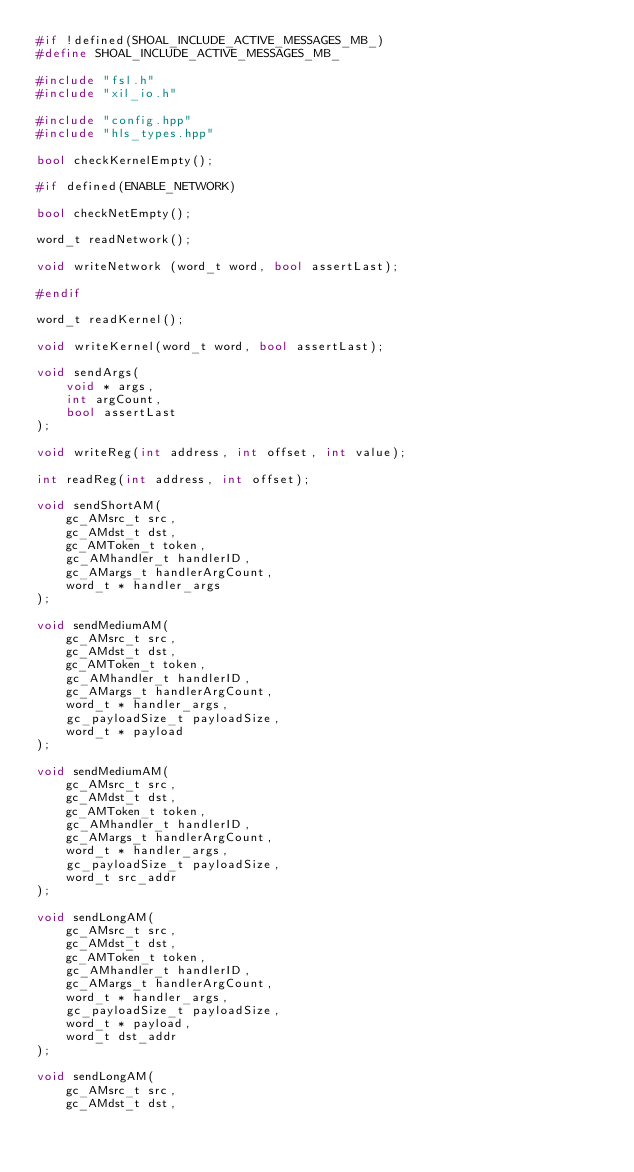Convert code to text. <code><loc_0><loc_0><loc_500><loc_500><_C++_>#if !defined(SHOAL_INCLUDE_ACTIVE_MESSAGES_MB_)
#define SHOAL_INCLUDE_ACTIVE_MESSAGES_MB_

#include "fsl.h"
#include "xil_io.h"

#include "config.hpp"
#include "hls_types.hpp"

bool checkKernelEmpty();

#if defined(ENABLE_NETWORK)

bool checkNetEmpty();

word_t readNetwork();

void writeNetwork (word_t word, bool assertLast);

#endif

word_t readKernel();

void writeKernel(word_t word, bool assertLast);

void sendArgs(
    void * args,
    int argCount,
    bool assertLast
);

void writeReg(int address, int offset, int value);

int readReg(int address, int offset);

void sendShortAM(
    gc_AMsrc_t src,
    gc_AMdst_t dst,
    gc_AMToken_t token,
    gc_AMhandler_t handlerID,
    gc_AMargs_t handlerArgCount,
    word_t * handler_args
);

void sendMediumAM(
    gc_AMsrc_t src,
    gc_AMdst_t dst,
    gc_AMToken_t token,
    gc_AMhandler_t handlerID,
    gc_AMargs_t handlerArgCount,
    word_t * handler_args,
    gc_payloadSize_t payloadSize,
    word_t * payload
);

void sendMediumAM(
    gc_AMsrc_t src,
    gc_AMdst_t dst,
    gc_AMToken_t token,
    gc_AMhandler_t handlerID,
    gc_AMargs_t handlerArgCount,
    word_t * handler_args,
    gc_payloadSize_t payloadSize,
    word_t src_addr
);

void sendLongAM(
    gc_AMsrc_t src,
    gc_AMdst_t dst,
    gc_AMToken_t token,
    gc_AMhandler_t handlerID,
    gc_AMargs_t handlerArgCount,
    word_t * handler_args,
    gc_payloadSize_t payloadSize,
    word_t * payload,
    word_t dst_addr
);

void sendLongAM(
    gc_AMsrc_t src,
    gc_AMdst_t dst,</code> 